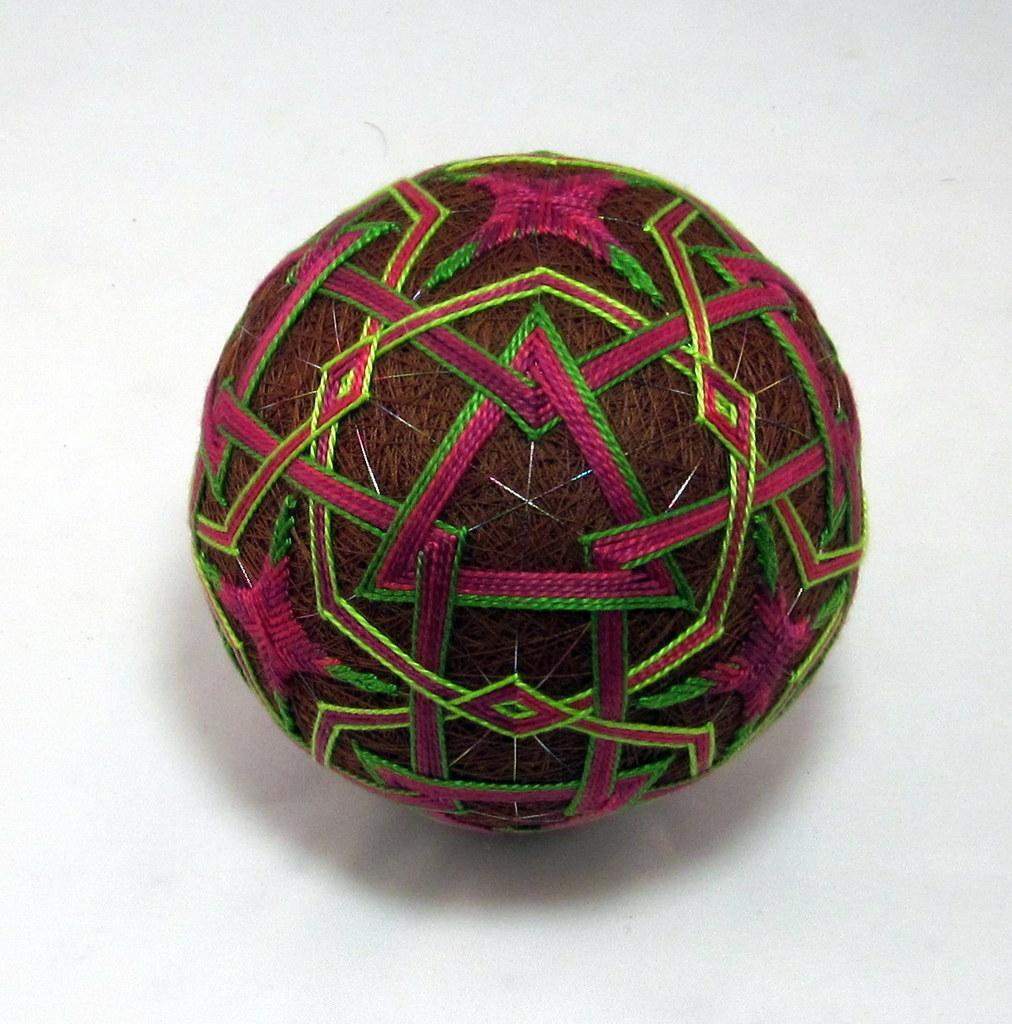Please provide a concise description of this image. In this picture we can see a ball made of threads is placed on a white platform. 